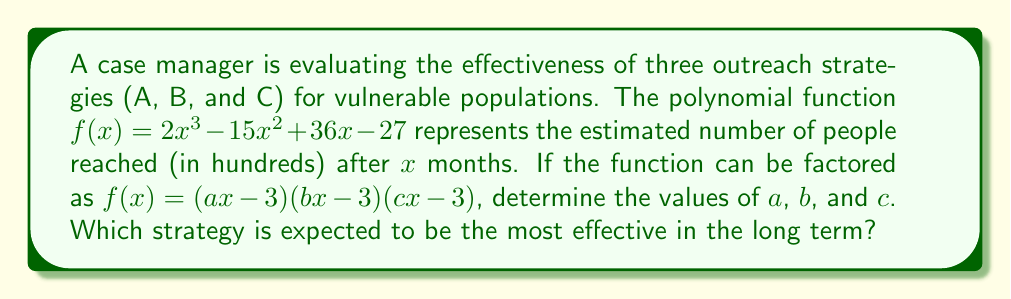Could you help me with this problem? 1) First, let's expand the factored form:
   $(ax-3)(bx-3)(cx-3) = abcx^3 - 3(ab+bc+ac)x^2 + 9(a+b+c)x - 27$

2) Comparing coefficients with the original function:
   $2x^3 - 15x^2 + 36x - 27$

3) We can deduce:
   $abc = 2$
   $3(ab+bc+ac) = 15$
   $9(a+b+c) = 36$

4) From the last equation:
   $a + b + c = 4$

5) Given that $abc = 2$ and $a + b + c = 4$, we can deduce that one of the factors must be 2 and the other two must be 1.

6) Let's assign $a = 2$, $b = 1$, and $c = 1$

7) Verifying:
   $2 \cdot 1 \cdot 1 = 2$
   $3(2\cdot1 + 1\cdot1 + 2\cdot1) = 3(4+1) = 15$
   $9(2+1+1) = 36$

8) The factored form is thus:
   $f(x) = (2x-3)(x-3)(x-3)$

9) Interpreting the results:
   - Strategy A (represented by $2x-3$) grows twice as fast as the others.
   - Strategies B and C (both represented by $x-3$) grow at the same rate.

Therefore, Strategy A is expected to be the most effective in the long term.
Answer: $a=2$, $b=1$, $c=1$; Strategy A is most effective 